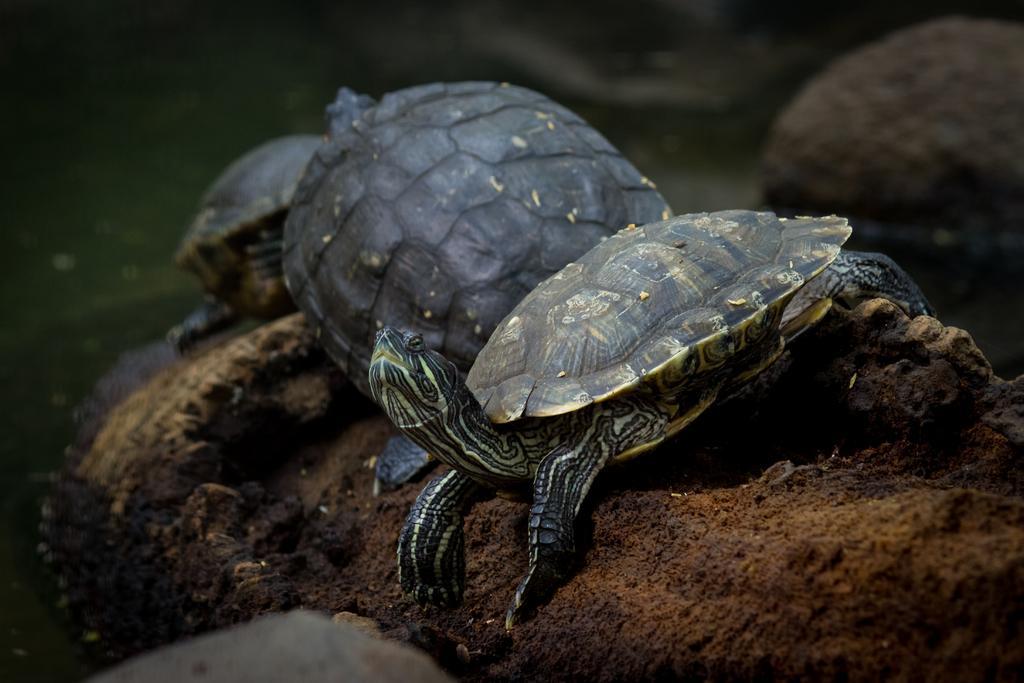How would you summarize this image in a sentence or two? In this image I can see in the middle it looks like there are turtles. 